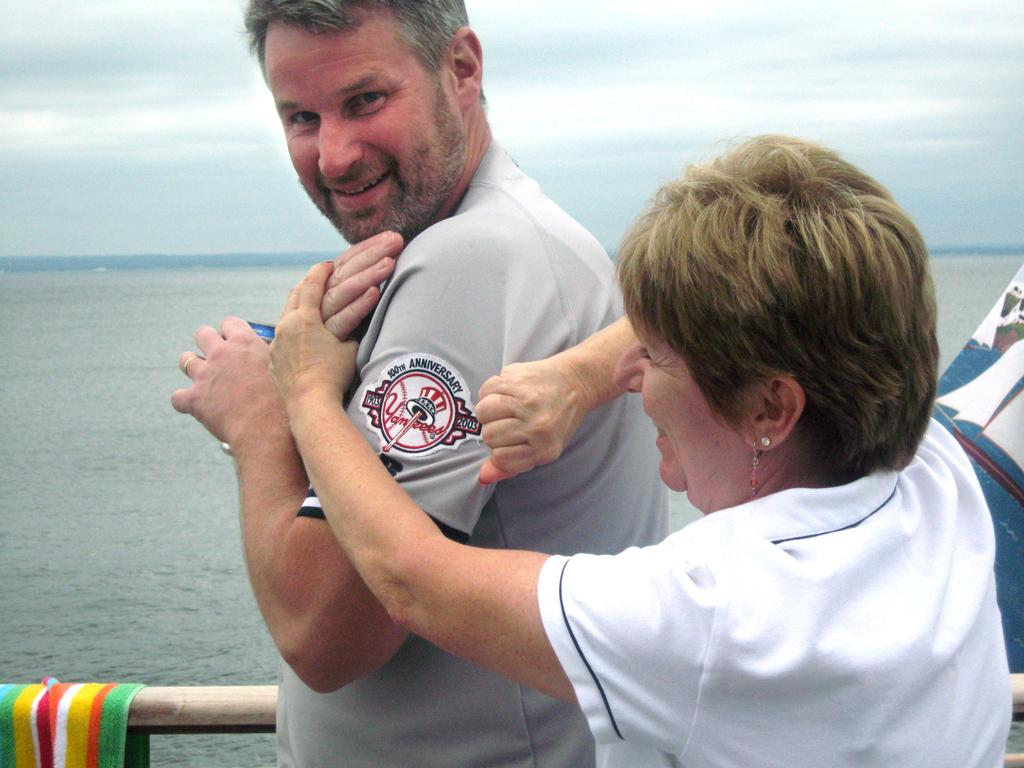<image>
Write a terse but informative summary of the picture. Man wearing a Yankees jersey and a woman trying to show it off. 